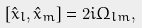Convert formula to latex. <formula><loc_0><loc_0><loc_500><loc_500>[ \hat { x } _ { l } , \hat { x } _ { m } ] = 2 i \Omega _ { l m } ,</formula> 